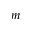Convert formula to latex. <formula><loc_0><loc_0><loc_500><loc_500>m</formula> 